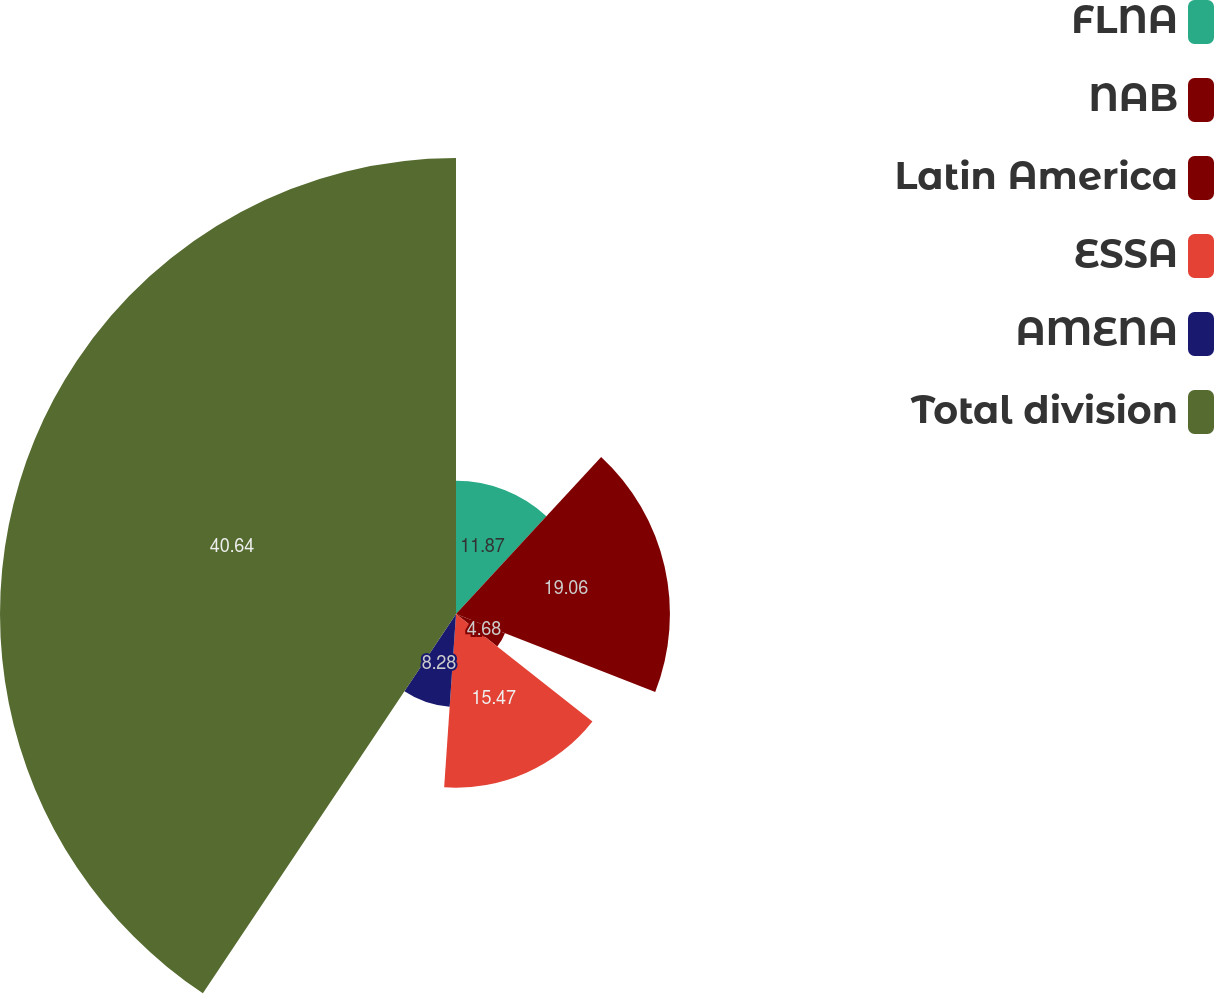Convert chart. <chart><loc_0><loc_0><loc_500><loc_500><pie_chart><fcel>FLNA<fcel>NAB<fcel>Latin America<fcel>ESSA<fcel>AMENA<fcel>Total division<nl><fcel>11.87%<fcel>19.06%<fcel>4.68%<fcel>15.47%<fcel>8.28%<fcel>40.63%<nl></chart> 